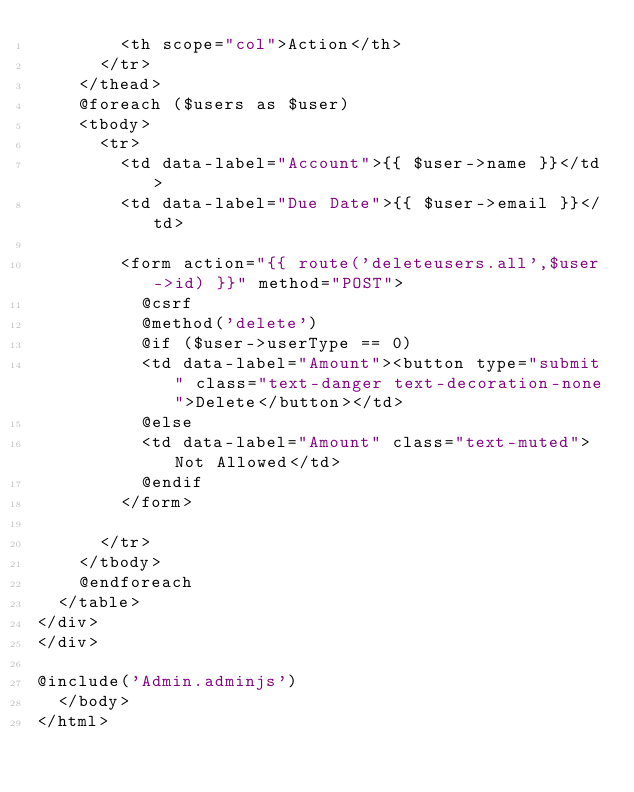Convert code to text. <code><loc_0><loc_0><loc_500><loc_500><_PHP_>        <th scope="col">Action</th>
      </tr>
    </thead>
    @foreach ($users as $user)
    <tbody>
      <tr>
        <td data-label="Account">{{ $user->name }}</td>
        <td data-label="Due Date">{{ $user->email }}</td>

        <form action="{{ route('deleteusers.all',$user->id) }}" method="POST">
          @csrf
          @method('delete')
          @if ($user->userType == 0)
          <td data-label="Amount"><button type="submit" class="text-danger text-decoration-none">Delete</button></td>
          @else
          <td data-label="Amount" class="text-muted">Not Allowed</td>
          @endif
        </form>
        
      </tr>
    </tbody>
    @endforeach
  </table>
</div>
</div>

@include('Admin.adminjs')
  </body>
</html>
</code> 